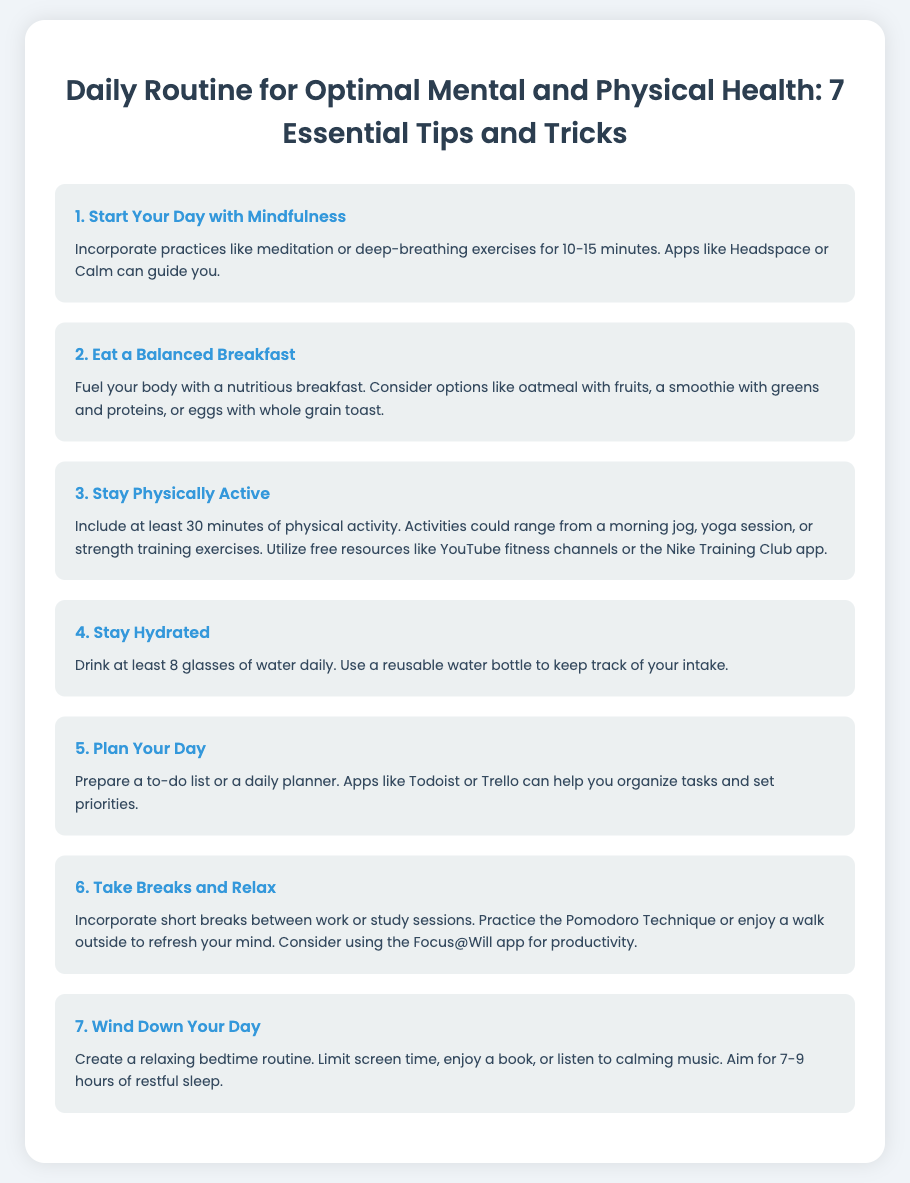What is the first tip for optimal health? The first tip listed in the infographic is about starting your day with mindfulness, which includes practices like meditation or deep-breathing exercises.
Answer: Start Your Day with Mindfulness How many tips are provided in the document? The document lists a total of seven essential tips for optimal mental and physical health.
Answer: 7 What should you drink at least daily? The document states that you should drink at least 8 glasses of water daily to stay hydrated.
Answer: 8 glasses Which app is suggested for guided meditation? The infographic mentions the app Headspace as a resource for guided meditation practices.
Answer: Headspace What is one activity mentioned for physical activity? The document provides examples such as a morning jog, yoga session, or strength training exercises.
Answer: Morning jog What bedtime routine is mentioned to wind down? The tip suggests creating a relaxing routine, including limiting screen time and enjoying a book.
Answer: Relaxing bedtime routine What technique is recommended for taking breaks? The document refers to the Pomodoro Technique as a method for incorporating breaks during work or study sessions.
Answer: Pomodoro Technique 